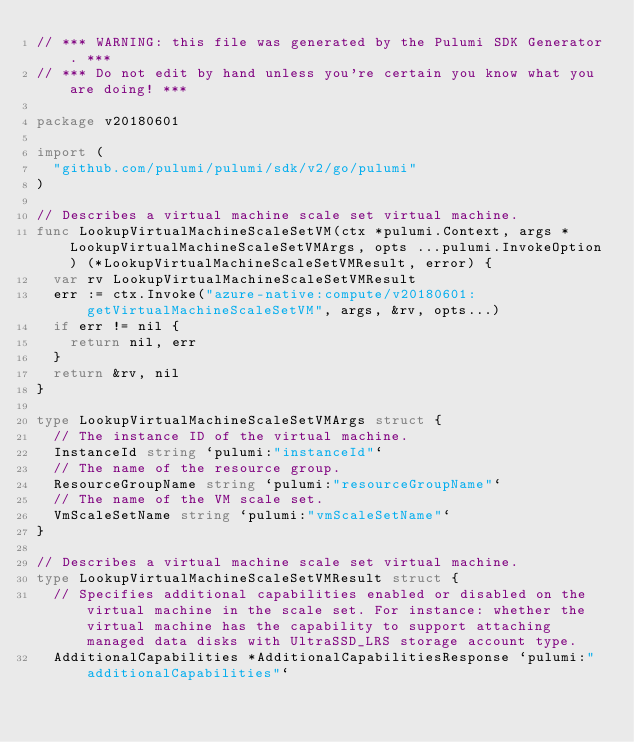Convert code to text. <code><loc_0><loc_0><loc_500><loc_500><_Go_>// *** WARNING: this file was generated by the Pulumi SDK Generator. ***
// *** Do not edit by hand unless you're certain you know what you are doing! ***

package v20180601

import (
	"github.com/pulumi/pulumi/sdk/v2/go/pulumi"
)

// Describes a virtual machine scale set virtual machine.
func LookupVirtualMachineScaleSetVM(ctx *pulumi.Context, args *LookupVirtualMachineScaleSetVMArgs, opts ...pulumi.InvokeOption) (*LookupVirtualMachineScaleSetVMResult, error) {
	var rv LookupVirtualMachineScaleSetVMResult
	err := ctx.Invoke("azure-native:compute/v20180601:getVirtualMachineScaleSetVM", args, &rv, opts...)
	if err != nil {
		return nil, err
	}
	return &rv, nil
}

type LookupVirtualMachineScaleSetVMArgs struct {
	// The instance ID of the virtual machine.
	InstanceId string `pulumi:"instanceId"`
	// The name of the resource group.
	ResourceGroupName string `pulumi:"resourceGroupName"`
	// The name of the VM scale set.
	VmScaleSetName string `pulumi:"vmScaleSetName"`
}

// Describes a virtual machine scale set virtual machine.
type LookupVirtualMachineScaleSetVMResult struct {
	// Specifies additional capabilities enabled or disabled on the virtual machine in the scale set. For instance: whether the virtual machine has the capability to support attaching managed data disks with UltraSSD_LRS storage account type.
	AdditionalCapabilities *AdditionalCapabilitiesResponse `pulumi:"additionalCapabilities"`</code> 